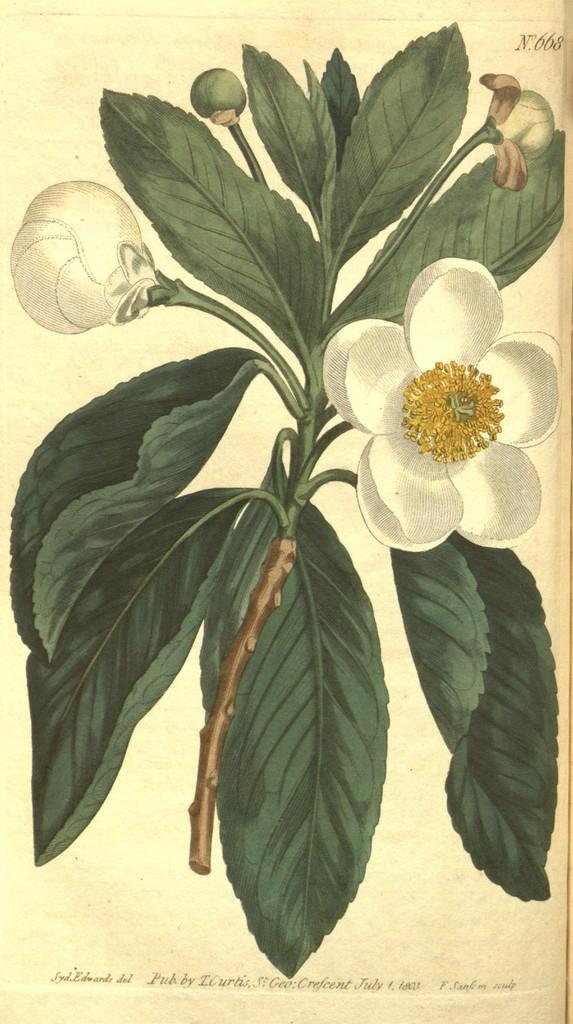What is depicted in the image? There is a drawing of a white flowers plant in the image. Can you describe the plant in the drawing? The plant has white flowers. Where is the kitty swimming in the image? There is no kitty present in the image. What type of goldfish can be seen in the image? There are no goldfish present in the image. 